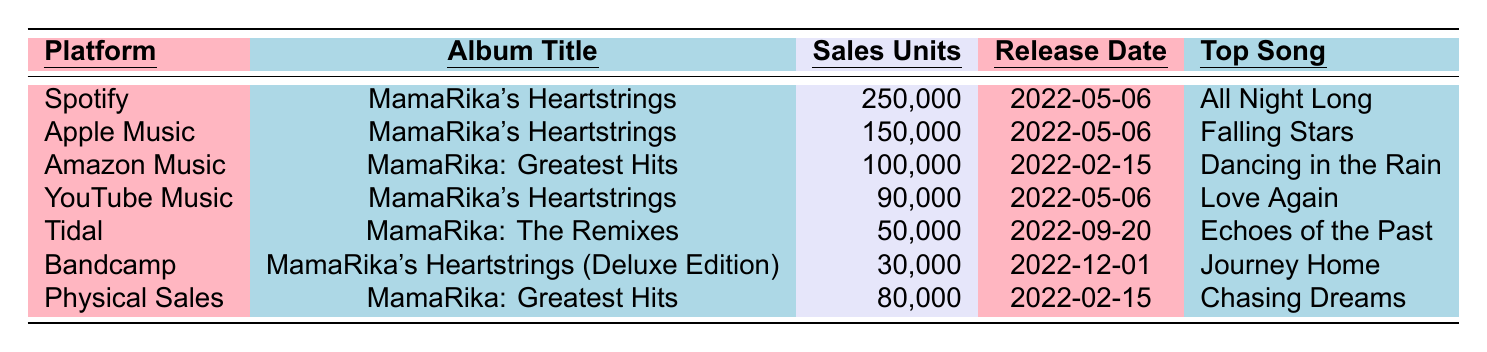What is the total number of album sales for "MamaRika's Heartstrings" across all platforms? The album "MamaRika's Heartstrings" has sales of 250,000 on Spotify, 150,000 on Apple Music, and 90,000 on YouTube Music. Adding these figures together: 250,000 + 150,000 + 90,000 = 490,000.
Answer: 490,000 Which platform has the highest album sales for MamaRika in 2022? By comparing the sales data, Spotify has the highest sales of 250,000 units, which is more than any other platform listed.
Answer: Spotify How many sales units did "MamaRika: Greatest Hits" achieve in total? "MamaRika: Greatest Hits" had sales of 100,000 on Amazon Music and 80,000 from physical sales. Adding these: 100,000 + 80,000 = 180,000 sales units.
Answer: 180,000 What is the top song from the album "MamaRika's Heartstrings"? The table indicates that the top song from "MamaRika's Heartstrings" is "All Night Long," which is listed under Spotify's sales data for this album.
Answer: All Night Long Did "MamaRika: The Remixes" have more or less than 60,000 sales units? The album "MamaRika: The Remixes" had 50,000 sales units, which is less than 60,000.
Answer: Less What is the average number of sales units across all platforms? First, we sum the sales units: 250,000 + 150,000 + 100,000 + 90,000 + 50,000 + 30,000 + 80,000 = 700,000. There are 7 entries, so dividing gives an average of 700,000 / 7 = 100,000.
Answer: 100,000 Which album was released first based on the data provided? "MamaRika: Greatest Hits" was released on 2022-02-15, which is earlier than the other albums listed, all released after this date.
Answer: MamaRika: Greatest Hits Is the top song for "MamaRika's Heartstrings (Deluxe Edition)" listed in the table? The table lists "Journey Home" as the top song for "MamaRika's Heartstrings (Deluxe Edition)".
Answer: Yes What were the total sales units for all albums released on the same date as "MamaRika's Heartstrings"? "MamaRika's Heartstrings" was released on 2022-05-06 and only shares this date with itself. Its units sold are 250,000 (Spotify) + 150,000 (Apple Music) + 90,000 (YouTube Music) = 490,000 units total for that date.
Answer: 490,000 